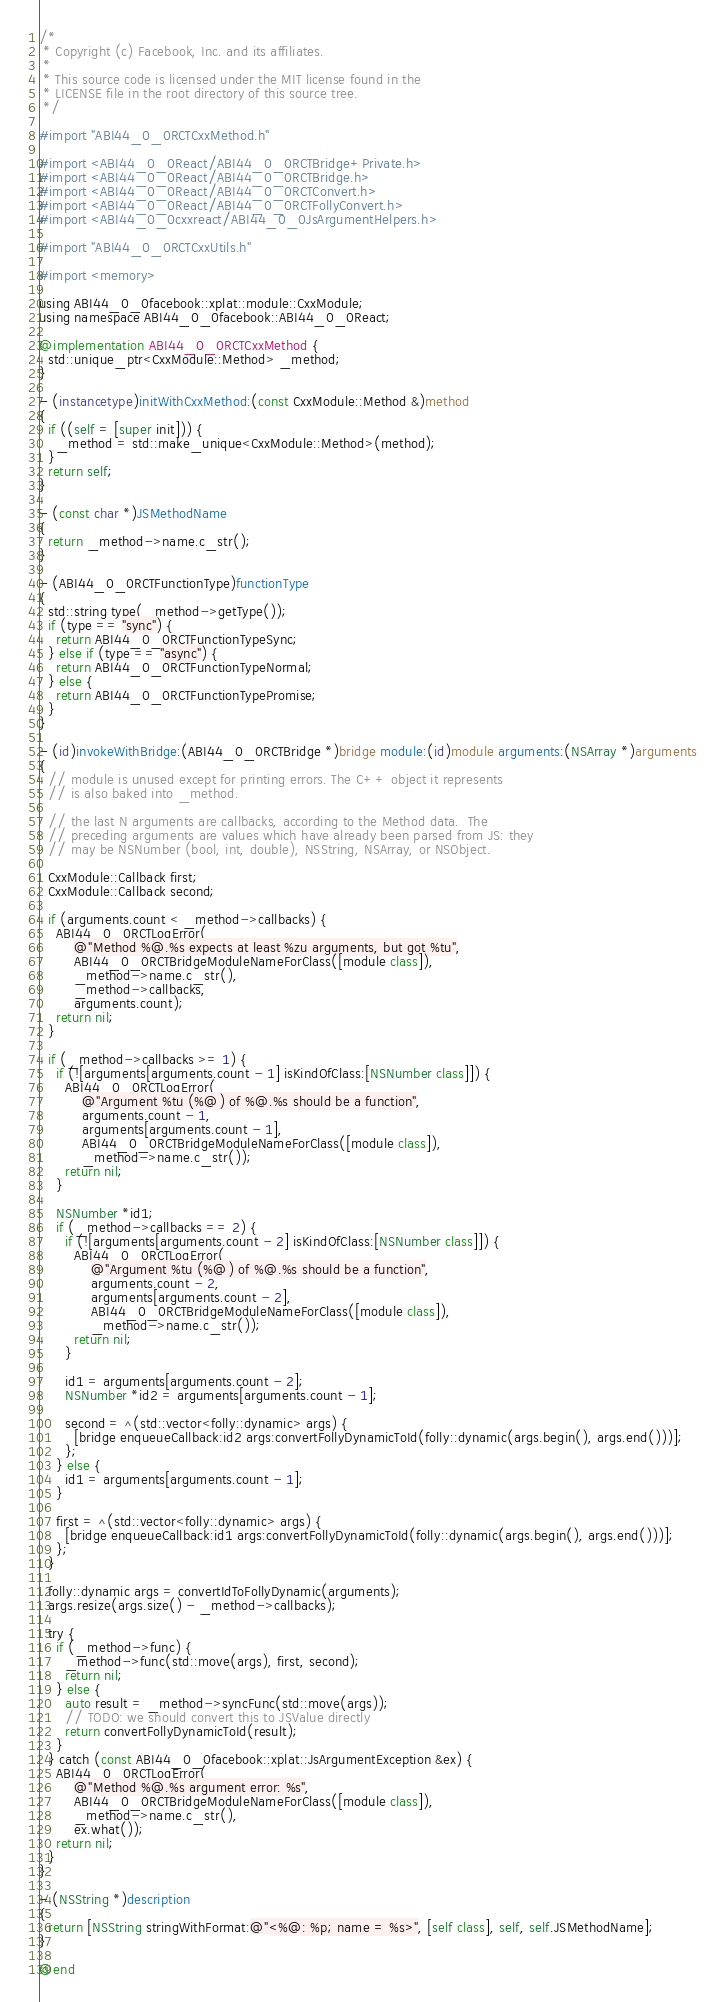<code> <loc_0><loc_0><loc_500><loc_500><_ObjectiveC_>/*
 * Copyright (c) Facebook, Inc. and its affiliates.
 *
 * This source code is licensed under the MIT license found in the
 * LICENSE file in the root directory of this source tree.
 */

#import "ABI44_0_0RCTCxxMethod.h"

#import <ABI44_0_0React/ABI44_0_0RCTBridge+Private.h>
#import <ABI44_0_0React/ABI44_0_0RCTBridge.h>
#import <ABI44_0_0React/ABI44_0_0RCTConvert.h>
#import <ABI44_0_0React/ABI44_0_0RCTFollyConvert.h>
#import <ABI44_0_0cxxreact/ABI44_0_0JsArgumentHelpers.h>

#import "ABI44_0_0RCTCxxUtils.h"

#import <memory>

using ABI44_0_0facebook::xplat::module::CxxModule;
using namespace ABI44_0_0facebook::ABI44_0_0React;

@implementation ABI44_0_0RCTCxxMethod {
  std::unique_ptr<CxxModule::Method> _method;
}

- (instancetype)initWithCxxMethod:(const CxxModule::Method &)method
{
  if ((self = [super init])) {
    _method = std::make_unique<CxxModule::Method>(method);
  }
  return self;
}

- (const char *)JSMethodName
{
  return _method->name.c_str();
}

- (ABI44_0_0RCTFunctionType)functionType
{
  std::string type(_method->getType());
  if (type == "sync") {
    return ABI44_0_0RCTFunctionTypeSync;
  } else if (type == "async") {
    return ABI44_0_0RCTFunctionTypeNormal;
  } else {
    return ABI44_0_0RCTFunctionTypePromise;
  }
}

- (id)invokeWithBridge:(ABI44_0_0RCTBridge *)bridge module:(id)module arguments:(NSArray *)arguments
{
  // module is unused except for printing errors. The C++ object it represents
  // is also baked into _method.

  // the last N arguments are callbacks, according to the Method data.  The
  // preceding arguments are values which have already been parsed from JS: they
  // may be NSNumber (bool, int, double), NSString, NSArray, or NSObject.

  CxxModule::Callback first;
  CxxModule::Callback second;

  if (arguments.count < _method->callbacks) {
    ABI44_0_0RCTLogError(
        @"Method %@.%s expects at least %zu arguments, but got %tu",
        ABI44_0_0RCTBridgeModuleNameForClass([module class]),
        _method->name.c_str(),
        _method->callbacks,
        arguments.count);
    return nil;
  }

  if (_method->callbacks >= 1) {
    if (![arguments[arguments.count - 1] isKindOfClass:[NSNumber class]]) {
      ABI44_0_0RCTLogError(
          @"Argument %tu (%@) of %@.%s should be a function",
          arguments.count - 1,
          arguments[arguments.count - 1],
          ABI44_0_0RCTBridgeModuleNameForClass([module class]),
          _method->name.c_str());
      return nil;
    }

    NSNumber *id1;
    if (_method->callbacks == 2) {
      if (![arguments[arguments.count - 2] isKindOfClass:[NSNumber class]]) {
        ABI44_0_0RCTLogError(
            @"Argument %tu (%@) of %@.%s should be a function",
            arguments.count - 2,
            arguments[arguments.count - 2],
            ABI44_0_0RCTBridgeModuleNameForClass([module class]),
            _method->name.c_str());
        return nil;
      }

      id1 = arguments[arguments.count - 2];
      NSNumber *id2 = arguments[arguments.count - 1];

      second = ^(std::vector<folly::dynamic> args) {
        [bridge enqueueCallback:id2 args:convertFollyDynamicToId(folly::dynamic(args.begin(), args.end()))];
      };
    } else {
      id1 = arguments[arguments.count - 1];
    }

    first = ^(std::vector<folly::dynamic> args) {
      [bridge enqueueCallback:id1 args:convertFollyDynamicToId(folly::dynamic(args.begin(), args.end()))];
    };
  }

  folly::dynamic args = convertIdToFollyDynamic(arguments);
  args.resize(args.size() - _method->callbacks);

  try {
    if (_method->func) {
      _method->func(std::move(args), first, second);
      return nil;
    } else {
      auto result = _method->syncFunc(std::move(args));
      // TODO: we should convert this to JSValue directly
      return convertFollyDynamicToId(result);
    }
  } catch (const ABI44_0_0facebook::xplat::JsArgumentException &ex) {
    ABI44_0_0RCTLogError(
        @"Method %@.%s argument error: %s",
        ABI44_0_0RCTBridgeModuleNameForClass([module class]),
        _method->name.c_str(),
        ex.what());
    return nil;
  }
}

- (NSString *)description
{
  return [NSString stringWithFormat:@"<%@: %p; name = %s>", [self class], self, self.JSMethodName];
}

@end
</code> 